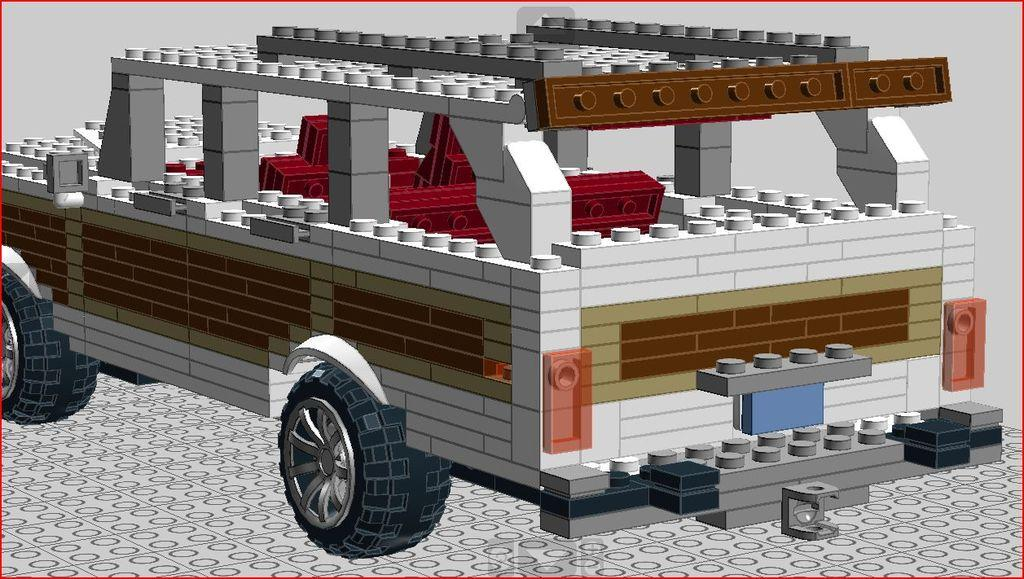What type of image is being described? The image is animated. What is one of the main subjects in the image? There is a vehicle in the image. How is the vehicle constructed? The vehicle is made with blocks. What part of the vehicle allows it to move on different surfaces? The vehicle has tires. How much income do the fairies in the image earn per year? There are no fairies present in the image, so it is not possible to determine their income. What tool is being used by the vehicle to build itself in the image? There is no tool, such as a hammer, present in the image. The vehicle is made with blocks, and the process of its construction is not depicted. 